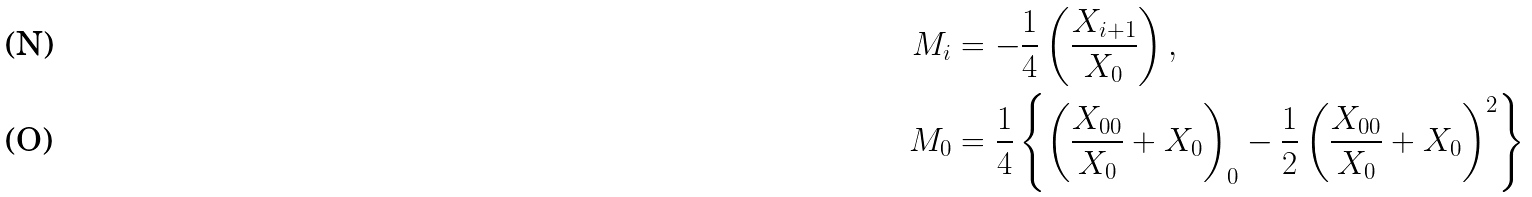<formula> <loc_0><loc_0><loc_500><loc_500>M _ { i } & = - \frac { 1 } { 4 } \left ( \frac { X _ { i + 1 } } { X _ { 0 } } \right ) , \\ M _ { 0 } & = \frac { 1 } { 4 } \left \{ \left ( \frac { X _ { 0 0 } } { X _ { 0 } } + X _ { 0 } \right ) _ { 0 } - \frac { 1 } { 2 } \left ( \frac { X _ { 0 0 } } { X _ { 0 } } + X _ { 0 } \right ) ^ { 2 } \right \}</formula> 